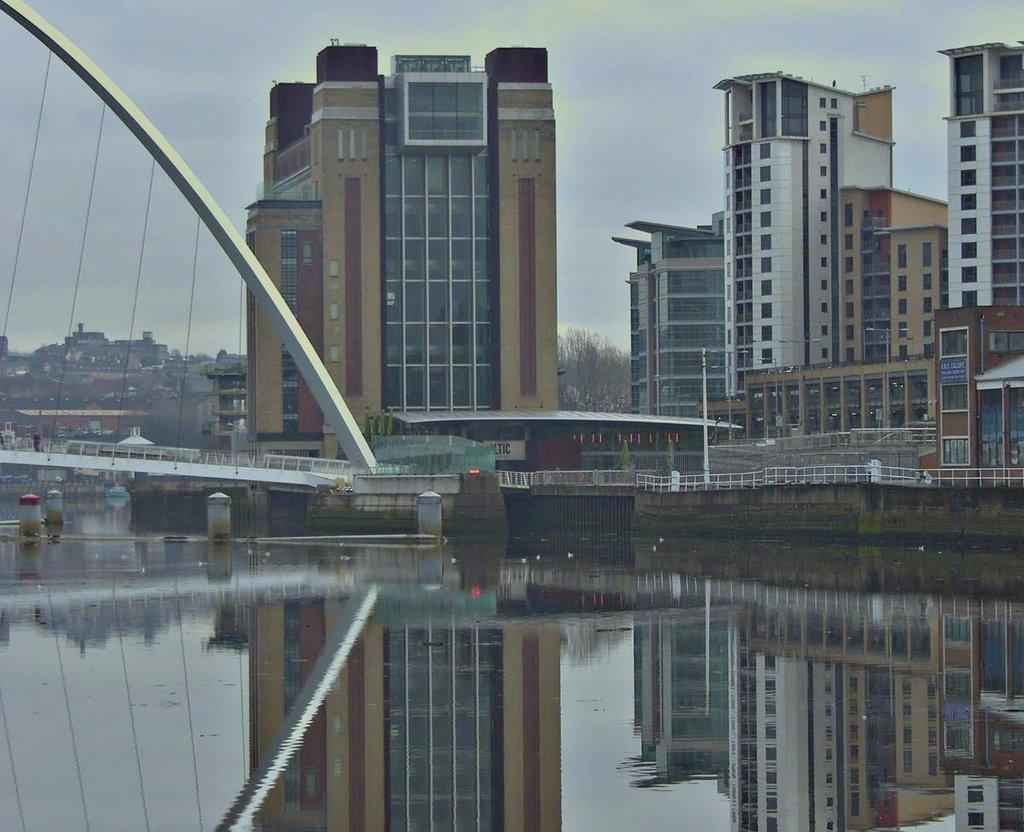What type of structure is present in the image? There is a bridge in the image. Where is the bridge located? The bridge is over water. What other features can be seen in the image? There is a fountain, buildings, a pole, a fence, and the sky is visible in the image. What type of vegetable is being used to power the fountain in the image? There is no vegetable present in the image, and the fountain's power source is not mentioned. 